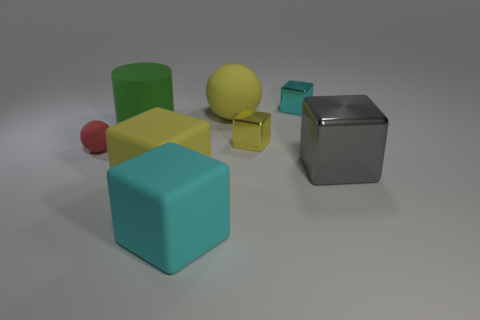Which objects might be soft to the touch? It's not possible to determine texture with absolute certainty from an image, but none of the objects displayed appear to inherently suggest they would be soft to the touch. They all seem to have hard surfaces. 